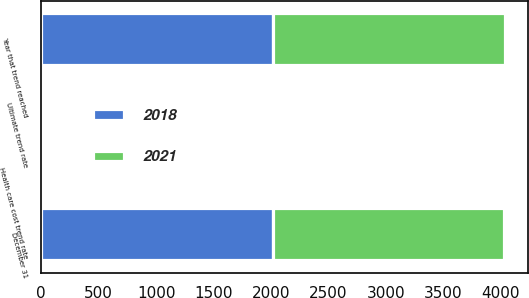Convert chart. <chart><loc_0><loc_0><loc_500><loc_500><stacked_bar_chart><ecel><fcel>December 31<fcel>Health care cost trend rate<fcel>Ultimate trend rate<fcel>Year that trend reached<nl><fcel>2018<fcel>2015<fcel>6.5<fcel>5<fcel>2021<nl><fcel>2021<fcel>2014<fcel>7<fcel>5<fcel>2018<nl></chart> 